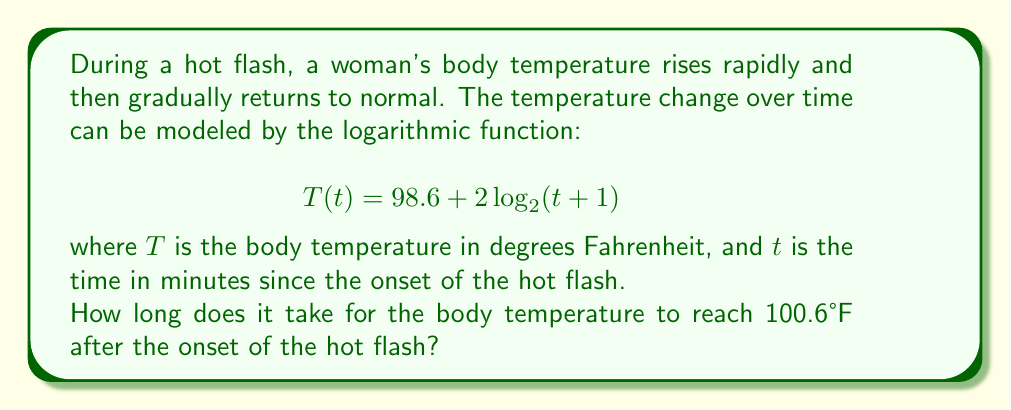Can you solve this math problem? To solve this problem, we need to follow these steps:

1) We're looking for the time $t$ when the temperature $T(t)$ reaches 100.6°F. So, we need to solve the equation:

   $$100.6 = 98.6 + 2\log_2(t+1)$$

2) Subtract 98.6 from both sides:

   $$2 = 2\log_2(t+1)$$

3) Divide both sides by 2:

   $$1 = \log_2(t+1)$$

4) Now, we can apply the inverse function (exponential) to both sides. Remember, $2^{\log_2(x)} = x$:

   $$2^1 = t+1$$

5) Simplify:

   $$2 = t+1$$

6) Subtract 1 from both sides:

   $$1 = t$$

Therefore, it takes 1 minute for the body temperature to reach 100.6°F after the onset of the hot flash.
Answer: 1 minute 